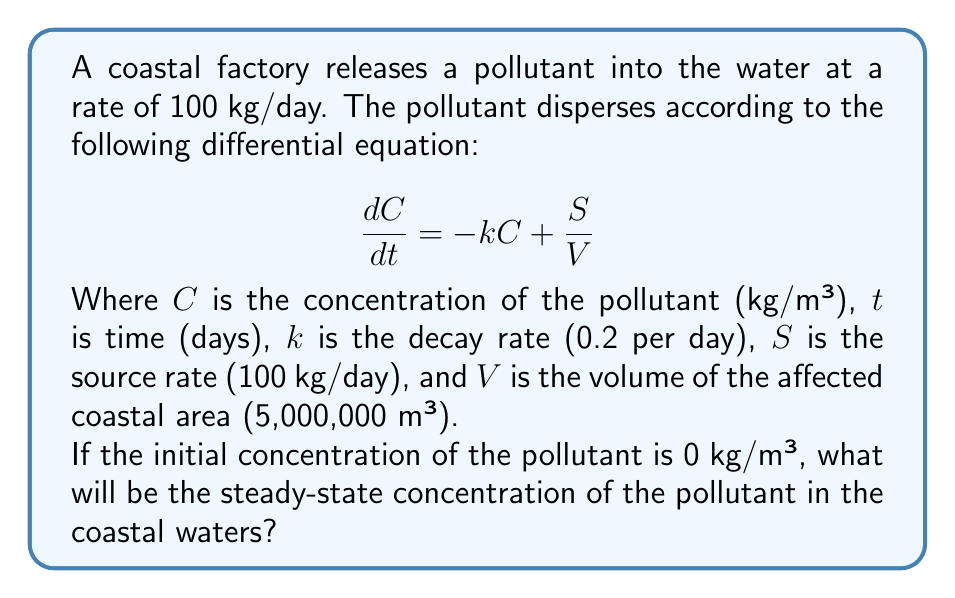Provide a solution to this math problem. To solve this problem, we need to follow these steps:

1) The steady-state concentration occurs when $\frac{dC}{dt} = 0$. At this point, the concentration is not changing with time.

2) Set the differential equation equal to zero:

   $$0 = -kC + \frac{S}{V}$$

3) Solve for $C$:

   $$kC = \frac{S}{V}$$
   $$C = \frac{S}{kV}$$

4) Now, substitute the given values:
   $S = 100$ kg/day
   $k = 0.2$ per day
   $V = 5,000,000$ m³

   $$C = \frac{100}{0.2 \times 5,000,000}$$

5) Simplify:
   $$C = \frac{100}{1,000,000} = 0.0001$$ kg/m³

Therefore, the steady-state concentration of the pollutant in the coastal waters will be 0.0001 kg/m³.
Answer: 0.0001 kg/m³ 